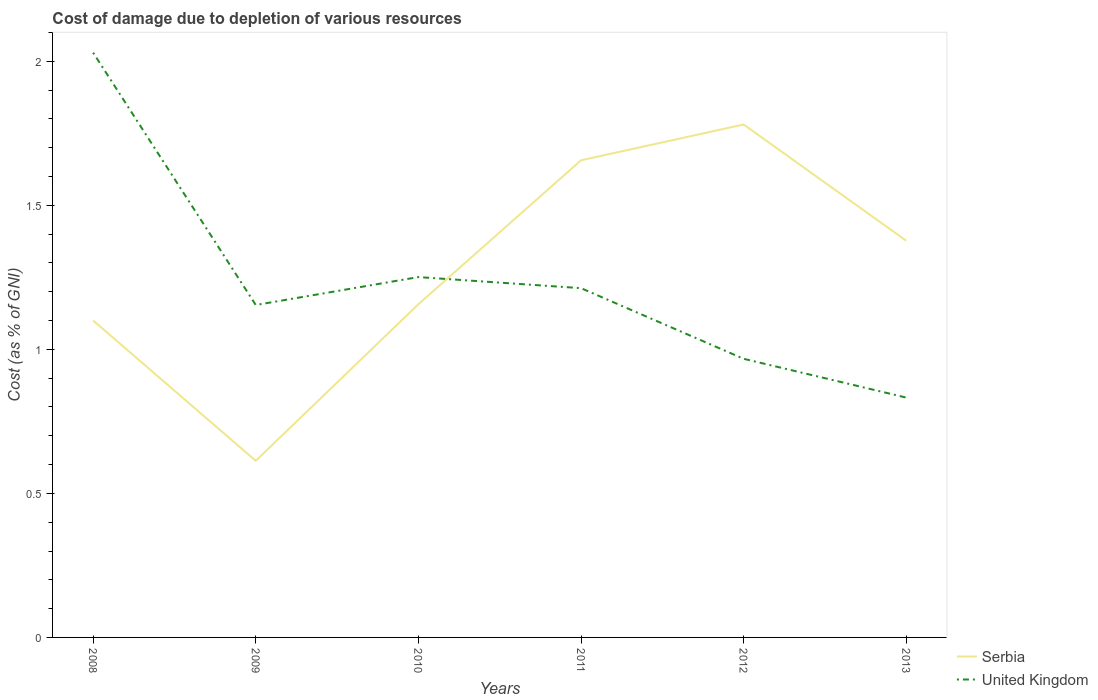Does the line corresponding to Serbia intersect with the line corresponding to United Kingdom?
Your response must be concise. Yes. Across all years, what is the maximum cost of damage caused due to the depletion of various resources in United Kingdom?
Your response must be concise. 0.83. What is the total cost of damage caused due to the depletion of various resources in Serbia in the graph?
Provide a short and direct response. -0.76. What is the difference between the highest and the second highest cost of damage caused due to the depletion of various resources in United Kingdom?
Provide a succinct answer. 1.2. What is the difference between the highest and the lowest cost of damage caused due to the depletion of various resources in United Kingdom?
Offer a terse response. 2. Is the cost of damage caused due to the depletion of various resources in Serbia strictly greater than the cost of damage caused due to the depletion of various resources in United Kingdom over the years?
Offer a terse response. No. Are the values on the major ticks of Y-axis written in scientific E-notation?
Offer a terse response. No. Does the graph contain any zero values?
Ensure brevity in your answer.  No. Where does the legend appear in the graph?
Ensure brevity in your answer.  Bottom right. What is the title of the graph?
Keep it short and to the point. Cost of damage due to depletion of various resources. Does "Aruba" appear as one of the legend labels in the graph?
Give a very brief answer. No. What is the label or title of the X-axis?
Offer a terse response. Years. What is the label or title of the Y-axis?
Give a very brief answer. Cost (as % of GNI). What is the Cost (as % of GNI) of Serbia in 2008?
Offer a terse response. 1.1. What is the Cost (as % of GNI) in United Kingdom in 2008?
Offer a very short reply. 2.03. What is the Cost (as % of GNI) of Serbia in 2009?
Offer a terse response. 0.61. What is the Cost (as % of GNI) of United Kingdom in 2009?
Give a very brief answer. 1.15. What is the Cost (as % of GNI) in Serbia in 2010?
Ensure brevity in your answer.  1.16. What is the Cost (as % of GNI) in United Kingdom in 2010?
Provide a succinct answer. 1.25. What is the Cost (as % of GNI) in Serbia in 2011?
Your answer should be very brief. 1.66. What is the Cost (as % of GNI) of United Kingdom in 2011?
Your answer should be compact. 1.21. What is the Cost (as % of GNI) of Serbia in 2012?
Your answer should be very brief. 1.78. What is the Cost (as % of GNI) in United Kingdom in 2012?
Your answer should be very brief. 0.97. What is the Cost (as % of GNI) of Serbia in 2013?
Ensure brevity in your answer.  1.38. What is the Cost (as % of GNI) of United Kingdom in 2013?
Provide a succinct answer. 0.83. Across all years, what is the maximum Cost (as % of GNI) of Serbia?
Keep it short and to the point. 1.78. Across all years, what is the maximum Cost (as % of GNI) of United Kingdom?
Your response must be concise. 2.03. Across all years, what is the minimum Cost (as % of GNI) in Serbia?
Offer a very short reply. 0.61. Across all years, what is the minimum Cost (as % of GNI) in United Kingdom?
Your answer should be very brief. 0.83. What is the total Cost (as % of GNI) in Serbia in the graph?
Your answer should be compact. 7.68. What is the total Cost (as % of GNI) in United Kingdom in the graph?
Ensure brevity in your answer.  7.45. What is the difference between the Cost (as % of GNI) in Serbia in 2008 and that in 2009?
Provide a short and direct response. 0.49. What is the difference between the Cost (as % of GNI) in United Kingdom in 2008 and that in 2009?
Keep it short and to the point. 0.88. What is the difference between the Cost (as % of GNI) of Serbia in 2008 and that in 2010?
Ensure brevity in your answer.  -0.06. What is the difference between the Cost (as % of GNI) in United Kingdom in 2008 and that in 2010?
Ensure brevity in your answer.  0.78. What is the difference between the Cost (as % of GNI) of Serbia in 2008 and that in 2011?
Your answer should be very brief. -0.56. What is the difference between the Cost (as % of GNI) of United Kingdom in 2008 and that in 2011?
Keep it short and to the point. 0.82. What is the difference between the Cost (as % of GNI) in Serbia in 2008 and that in 2012?
Offer a terse response. -0.68. What is the difference between the Cost (as % of GNI) in United Kingdom in 2008 and that in 2012?
Keep it short and to the point. 1.06. What is the difference between the Cost (as % of GNI) in Serbia in 2008 and that in 2013?
Provide a short and direct response. -0.28. What is the difference between the Cost (as % of GNI) of United Kingdom in 2008 and that in 2013?
Provide a short and direct response. 1.2. What is the difference between the Cost (as % of GNI) in Serbia in 2009 and that in 2010?
Ensure brevity in your answer.  -0.54. What is the difference between the Cost (as % of GNI) in United Kingdom in 2009 and that in 2010?
Make the answer very short. -0.1. What is the difference between the Cost (as % of GNI) of Serbia in 2009 and that in 2011?
Ensure brevity in your answer.  -1.04. What is the difference between the Cost (as % of GNI) in United Kingdom in 2009 and that in 2011?
Your response must be concise. -0.06. What is the difference between the Cost (as % of GNI) in Serbia in 2009 and that in 2012?
Keep it short and to the point. -1.17. What is the difference between the Cost (as % of GNI) in United Kingdom in 2009 and that in 2012?
Provide a short and direct response. 0.19. What is the difference between the Cost (as % of GNI) in Serbia in 2009 and that in 2013?
Keep it short and to the point. -0.76. What is the difference between the Cost (as % of GNI) of United Kingdom in 2009 and that in 2013?
Provide a short and direct response. 0.32. What is the difference between the Cost (as % of GNI) in Serbia in 2010 and that in 2011?
Provide a succinct answer. -0.5. What is the difference between the Cost (as % of GNI) in United Kingdom in 2010 and that in 2011?
Provide a short and direct response. 0.04. What is the difference between the Cost (as % of GNI) in Serbia in 2010 and that in 2012?
Provide a short and direct response. -0.62. What is the difference between the Cost (as % of GNI) in United Kingdom in 2010 and that in 2012?
Your answer should be compact. 0.28. What is the difference between the Cost (as % of GNI) in Serbia in 2010 and that in 2013?
Offer a terse response. -0.22. What is the difference between the Cost (as % of GNI) of United Kingdom in 2010 and that in 2013?
Keep it short and to the point. 0.42. What is the difference between the Cost (as % of GNI) in Serbia in 2011 and that in 2012?
Provide a succinct answer. -0.12. What is the difference between the Cost (as % of GNI) in United Kingdom in 2011 and that in 2012?
Make the answer very short. 0.25. What is the difference between the Cost (as % of GNI) in Serbia in 2011 and that in 2013?
Offer a terse response. 0.28. What is the difference between the Cost (as % of GNI) in United Kingdom in 2011 and that in 2013?
Provide a short and direct response. 0.38. What is the difference between the Cost (as % of GNI) of Serbia in 2012 and that in 2013?
Ensure brevity in your answer.  0.4. What is the difference between the Cost (as % of GNI) of United Kingdom in 2012 and that in 2013?
Offer a terse response. 0.13. What is the difference between the Cost (as % of GNI) in Serbia in 2008 and the Cost (as % of GNI) in United Kingdom in 2009?
Your response must be concise. -0.05. What is the difference between the Cost (as % of GNI) of Serbia in 2008 and the Cost (as % of GNI) of United Kingdom in 2010?
Give a very brief answer. -0.15. What is the difference between the Cost (as % of GNI) of Serbia in 2008 and the Cost (as % of GNI) of United Kingdom in 2011?
Keep it short and to the point. -0.11. What is the difference between the Cost (as % of GNI) in Serbia in 2008 and the Cost (as % of GNI) in United Kingdom in 2012?
Provide a succinct answer. 0.13. What is the difference between the Cost (as % of GNI) of Serbia in 2008 and the Cost (as % of GNI) of United Kingdom in 2013?
Make the answer very short. 0.27. What is the difference between the Cost (as % of GNI) of Serbia in 2009 and the Cost (as % of GNI) of United Kingdom in 2010?
Make the answer very short. -0.64. What is the difference between the Cost (as % of GNI) in Serbia in 2009 and the Cost (as % of GNI) in United Kingdom in 2011?
Make the answer very short. -0.6. What is the difference between the Cost (as % of GNI) in Serbia in 2009 and the Cost (as % of GNI) in United Kingdom in 2012?
Give a very brief answer. -0.35. What is the difference between the Cost (as % of GNI) of Serbia in 2009 and the Cost (as % of GNI) of United Kingdom in 2013?
Keep it short and to the point. -0.22. What is the difference between the Cost (as % of GNI) in Serbia in 2010 and the Cost (as % of GNI) in United Kingdom in 2011?
Keep it short and to the point. -0.06. What is the difference between the Cost (as % of GNI) of Serbia in 2010 and the Cost (as % of GNI) of United Kingdom in 2012?
Your answer should be compact. 0.19. What is the difference between the Cost (as % of GNI) of Serbia in 2010 and the Cost (as % of GNI) of United Kingdom in 2013?
Provide a short and direct response. 0.32. What is the difference between the Cost (as % of GNI) in Serbia in 2011 and the Cost (as % of GNI) in United Kingdom in 2012?
Keep it short and to the point. 0.69. What is the difference between the Cost (as % of GNI) in Serbia in 2011 and the Cost (as % of GNI) in United Kingdom in 2013?
Offer a terse response. 0.82. What is the difference between the Cost (as % of GNI) in Serbia in 2012 and the Cost (as % of GNI) in United Kingdom in 2013?
Ensure brevity in your answer.  0.95. What is the average Cost (as % of GNI) in Serbia per year?
Make the answer very short. 1.28. What is the average Cost (as % of GNI) of United Kingdom per year?
Offer a terse response. 1.24. In the year 2008, what is the difference between the Cost (as % of GNI) in Serbia and Cost (as % of GNI) in United Kingdom?
Your answer should be very brief. -0.93. In the year 2009, what is the difference between the Cost (as % of GNI) of Serbia and Cost (as % of GNI) of United Kingdom?
Your answer should be very brief. -0.54. In the year 2010, what is the difference between the Cost (as % of GNI) in Serbia and Cost (as % of GNI) in United Kingdom?
Offer a very short reply. -0.09. In the year 2011, what is the difference between the Cost (as % of GNI) in Serbia and Cost (as % of GNI) in United Kingdom?
Offer a terse response. 0.44. In the year 2012, what is the difference between the Cost (as % of GNI) of Serbia and Cost (as % of GNI) of United Kingdom?
Ensure brevity in your answer.  0.81. In the year 2013, what is the difference between the Cost (as % of GNI) in Serbia and Cost (as % of GNI) in United Kingdom?
Your answer should be very brief. 0.54. What is the ratio of the Cost (as % of GNI) of Serbia in 2008 to that in 2009?
Provide a short and direct response. 1.79. What is the ratio of the Cost (as % of GNI) in United Kingdom in 2008 to that in 2009?
Keep it short and to the point. 1.76. What is the ratio of the Cost (as % of GNI) of Serbia in 2008 to that in 2010?
Ensure brevity in your answer.  0.95. What is the ratio of the Cost (as % of GNI) in United Kingdom in 2008 to that in 2010?
Offer a very short reply. 1.62. What is the ratio of the Cost (as % of GNI) of Serbia in 2008 to that in 2011?
Offer a very short reply. 0.66. What is the ratio of the Cost (as % of GNI) of United Kingdom in 2008 to that in 2011?
Your answer should be very brief. 1.67. What is the ratio of the Cost (as % of GNI) of Serbia in 2008 to that in 2012?
Make the answer very short. 0.62. What is the ratio of the Cost (as % of GNI) of United Kingdom in 2008 to that in 2012?
Provide a short and direct response. 2.1. What is the ratio of the Cost (as % of GNI) of Serbia in 2008 to that in 2013?
Offer a very short reply. 0.8. What is the ratio of the Cost (as % of GNI) of United Kingdom in 2008 to that in 2013?
Give a very brief answer. 2.44. What is the ratio of the Cost (as % of GNI) of Serbia in 2009 to that in 2010?
Your answer should be compact. 0.53. What is the ratio of the Cost (as % of GNI) in United Kingdom in 2009 to that in 2010?
Offer a terse response. 0.92. What is the ratio of the Cost (as % of GNI) in Serbia in 2009 to that in 2011?
Offer a very short reply. 0.37. What is the ratio of the Cost (as % of GNI) in United Kingdom in 2009 to that in 2011?
Your response must be concise. 0.95. What is the ratio of the Cost (as % of GNI) of Serbia in 2009 to that in 2012?
Your response must be concise. 0.34. What is the ratio of the Cost (as % of GNI) of United Kingdom in 2009 to that in 2012?
Ensure brevity in your answer.  1.19. What is the ratio of the Cost (as % of GNI) in Serbia in 2009 to that in 2013?
Offer a very short reply. 0.45. What is the ratio of the Cost (as % of GNI) of United Kingdom in 2009 to that in 2013?
Give a very brief answer. 1.39. What is the ratio of the Cost (as % of GNI) in Serbia in 2010 to that in 2011?
Your answer should be very brief. 0.7. What is the ratio of the Cost (as % of GNI) in United Kingdom in 2010 to that in 2011?
Your answer should be compact. 1.03. What is the ratio of the Cost (as % of GNI) in Serbia in 2010 to that in 2012?
Provide a short and direct response. 0.65. What is the ratio of the Cost (as % of GNI) in United Kingdom in 2010 to that in 2012?
Provide a short and direct response. 1.29. What is the ratio of the Cost (as % of GNI) in Serbia in 2010 to that in 2013?
Offer a terse response. 0.84. What is the ratio of the Cost (as % of GNI) of United Kingdom in 2010 to that in 2013?
Provide a succinct answer. 1.5. What is the ratio of the Cost (as % of GNI) in Serbia in 2011 to that in 2012?
Your response must be concise. 0.93. What is the ratio of the Cost (as % of GNI) in United Kingdom in 2011 to that in 2012?
Keep it short and to the point. 1.25. What is the ratio of the Cost (as % of GNI) in Serbia in 2011 to that in 2013?
Offer a terse response. 1.2. What is the ratio of the Cost (as % of GNI) in United Kingdom in 2011 to that in 2013?
Provide a succinct answer. 1.46. What is the ratio of the Cost (as % of GNI) of Serbia in 2012 to that in 2013?
Ensure brevity in your answer.  1.29. What is the ratio of the Cost (as % of GNI) of United Kingdom in 2012 to that in 2013?
Ensure brevity in your answer.  1.16. What is the difference between the highest and the second highest Cost (as % of GNI) in Serbia?
Keep it short and to the point. 0.12. What is the difference between the highest and the second highest Cost (as % of GNI) of United Kingdom?
Keep it short and to the point. 0.78. What is the difference between the highest and the lowest Cost (as % of GNI) in Serbia?
Provide a succinct answer. 1.17. What is the difference between the highest and the lowest Cost (as % of GNI) in United Kingdom?
Your answer should be very brief. 1.2. 